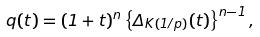<formula> <loc_0><loc_0><loc_500><loc_500>q ( t ) = ( 1 + t ) ^ { n } \left \{ \Delta _ { K ( 1 / p ) } ( t ) \right \} ^ { n - 1 } ,</formula> 